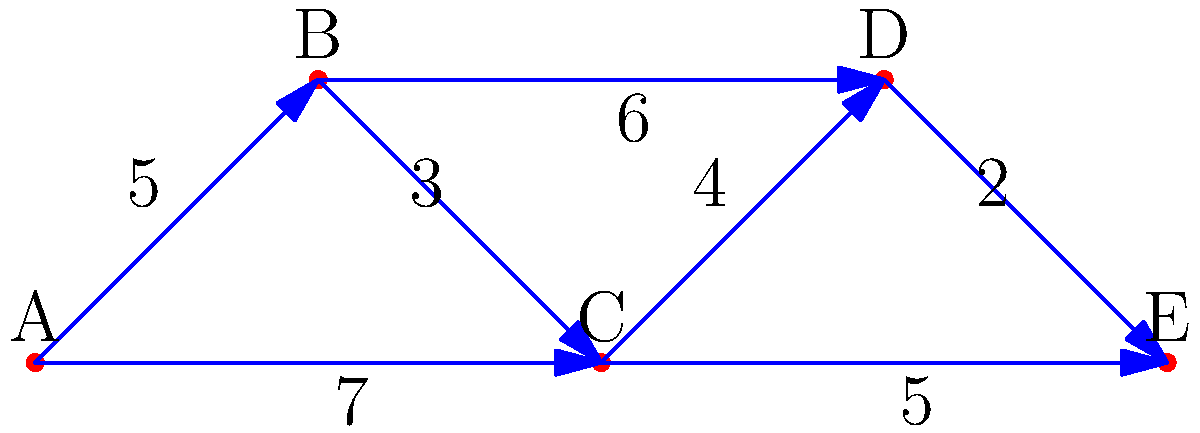An airport in a rapidly developing Chinese city is planning to expand its terminal connections. The diagram shows the potential connections between terminals A, B, C, D, and E, with the associated costs (in millions of yuan) for each connection. What is the minimum total cost to ensure all terminals are connected, either directly or indirectly? To find the minimum total cost to connect all terminals, we need to use the concept of a Minimum Spanning Tree (MST). Here's how to solve this problem step-by-step:

1. Identify all edges and their weights:
   AB: 5, BC: 3, CD: 4, DE: 2, AC: 7, BD: 6, CE: 5

2. Sort the edges by weight in ascending order:
   DE: 2, BC: 3, CD: 4, AB: 5, CE: 5, BD: 6, AC: 7

3. Apply Kruskal's algorithm to find the MST:
   a) Add DE (2) to the MST
   b) Add BC (3) to the MST
   c) Add CD (4) to the MST
   d) Add AB (5) to the MST

4. At this point, all terminals are connected, and we have the MST.

5. Calculate the total cost by summing the weights of the selected edges:
   Total cost = 2 + 3 + 4 + 5 = 14 million yuan

Therefore, the minimum total cost to ensure all terminals are connected is 14 million yuan.
Answer: 14 million yuan 